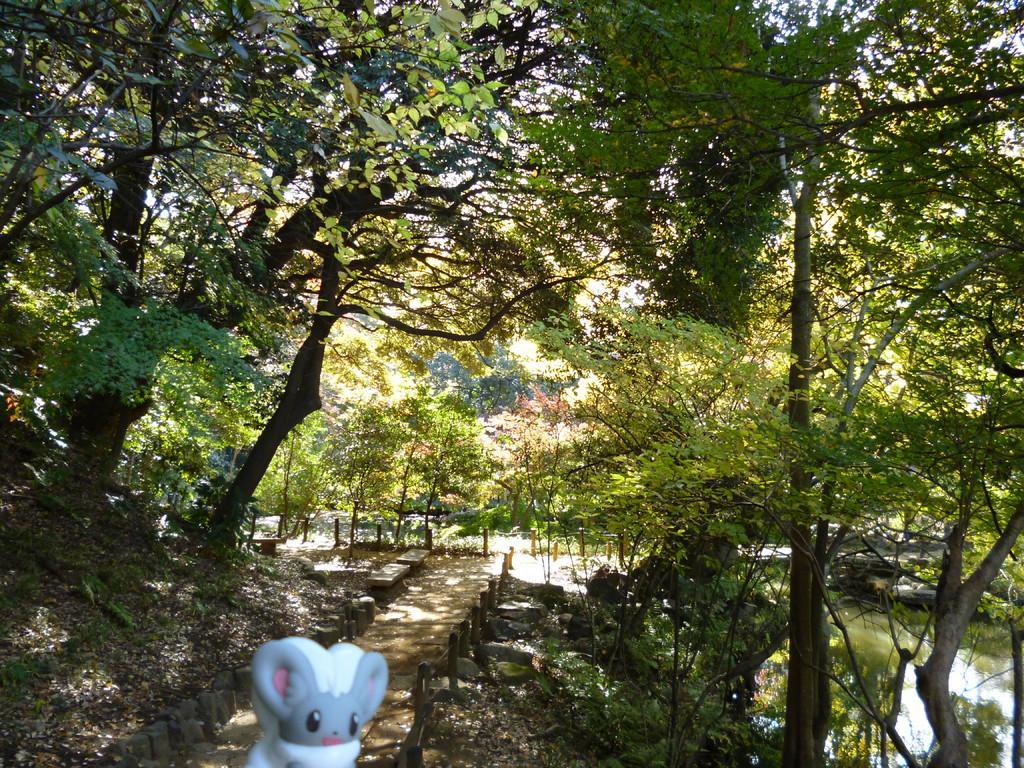Please provide a concise description of this image. In the foreground of this picture we can see a toy and we can see an alley, plants, trees and a water body. In the background we can see the trees, rocks and some other items. 